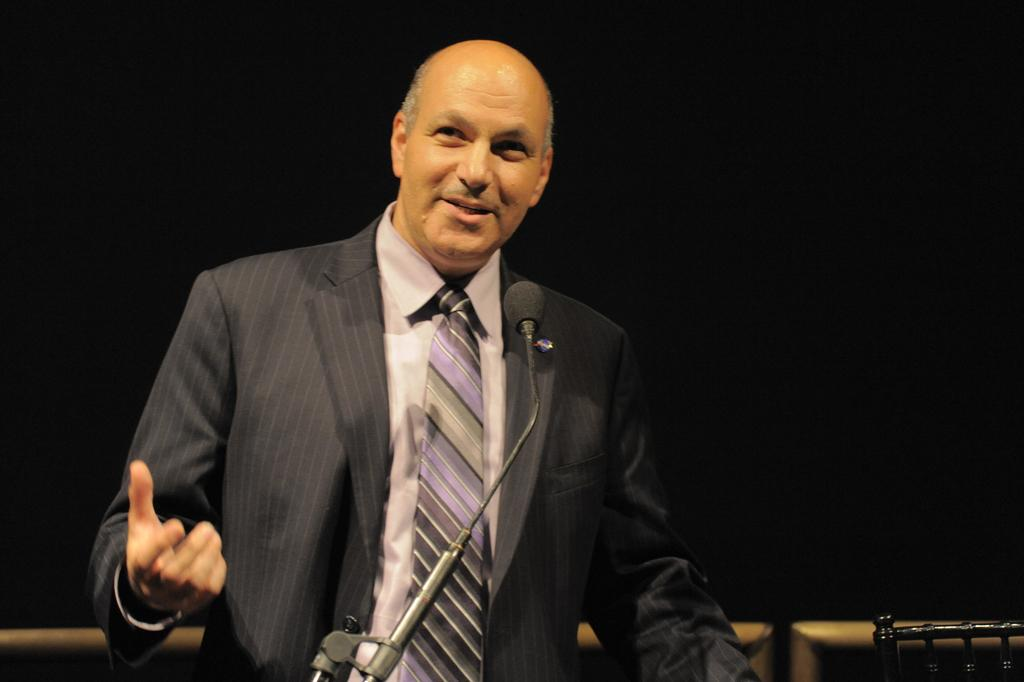Who is present in the image? There is a man in the image. What is the man wearing? The man is wearing a coat and tie. What expression does the man have? The man is smiling. What object is in front of the man? There is a mic in front of the man. What can be observed about the background of the image? The background of the image is dark. What type of crown is the man wearing in the image? There is no crown present in the image; the man is wearing a coat and tie. What tax-related information can be seen in the image? There is no tax-related information present in the image. 